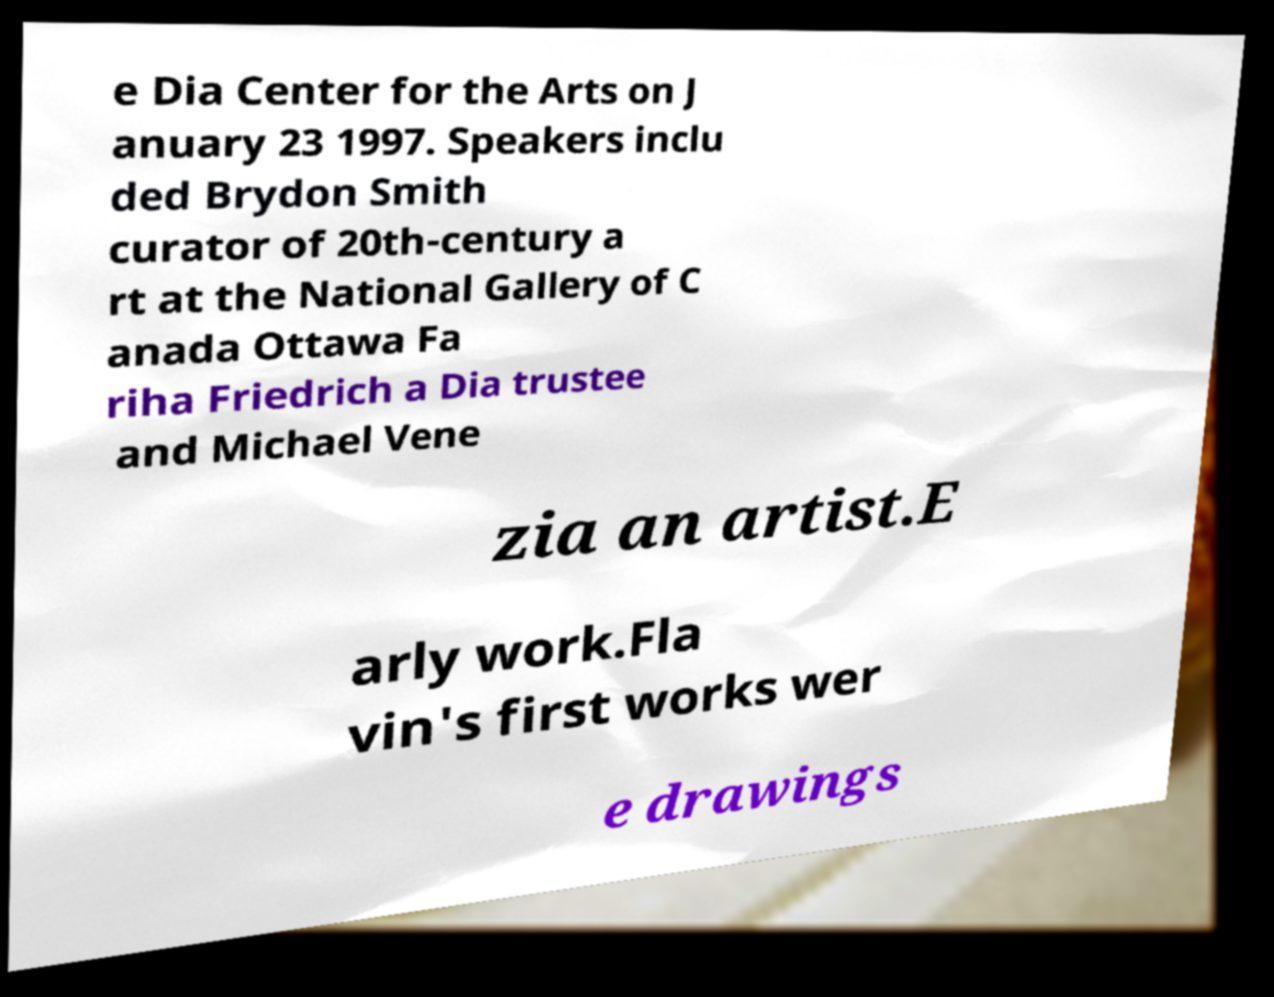Could you extract and type out the text from this image? e Dia Center for the Arts on J anuary 23 1997. Speakers inclu ded Brydon Smith curator of 20th-century a rt at the National Gallery of C anada Ottawa Fa riha Friedrich a Dia trustee and Michael Vene zia an artist.E arly work.Fla vin's first works wer e drawings 